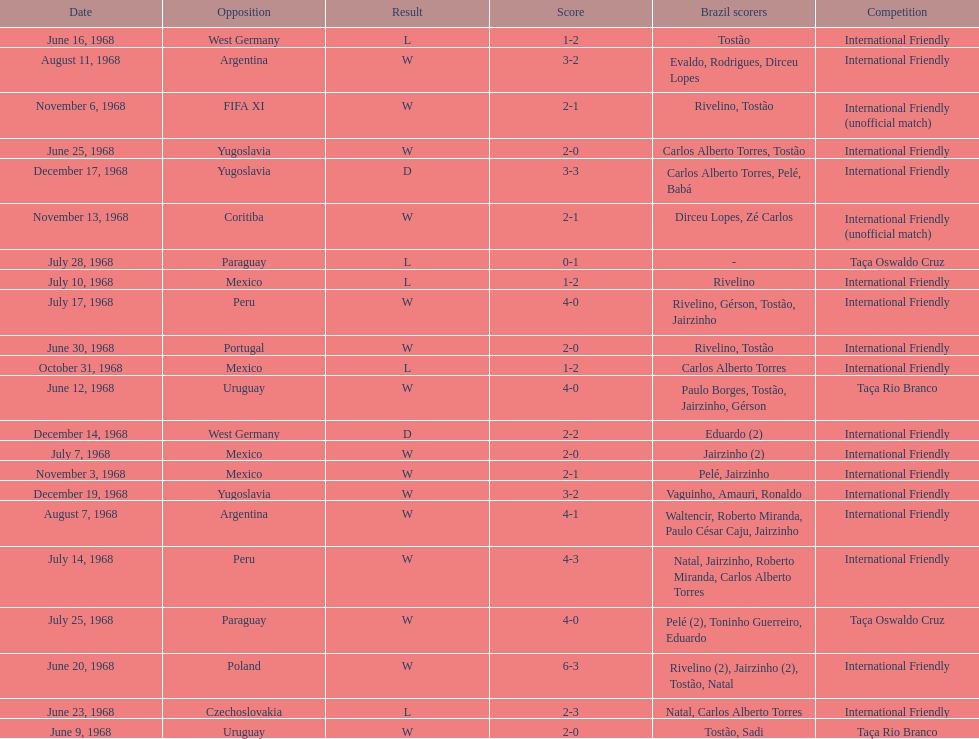What's the total number of ties? 2. 